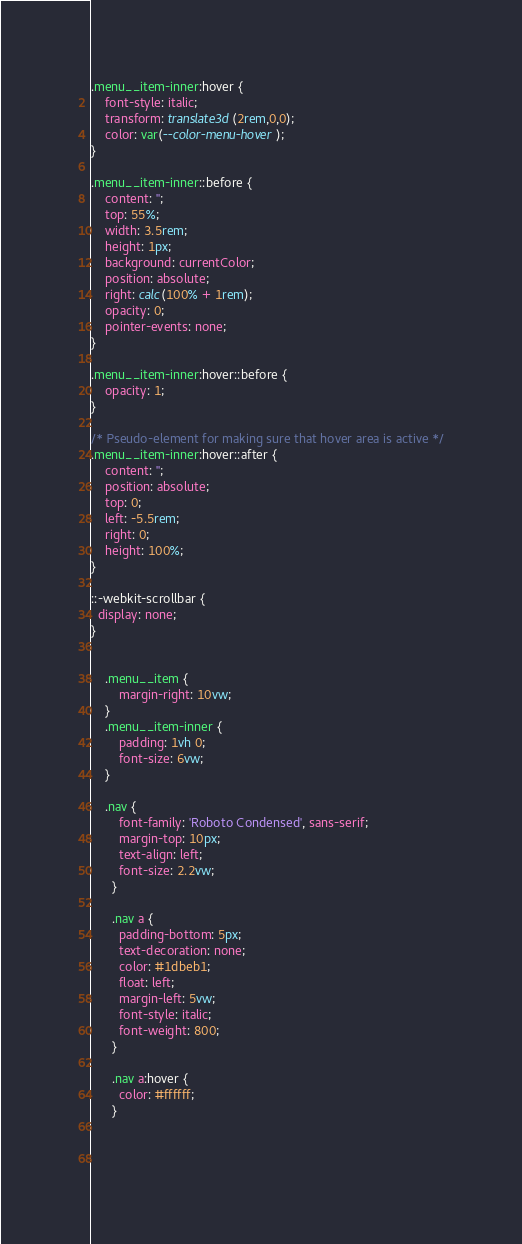<code> <loc_0><loc_0><loc_500><loc_500><_CSS_>.menu__item-inner:hover {
	font-style: italic;
	transform: translate3d(2rem,0,0);
	color: var(--color-menu-hover);
}

.menu__item-inner::before {
	content: '';
	top: 55%;
	width: 3.5rem;
	height: 1px;
	background: currentColor;
	position: absolute;
	right: calc(100% + 1rem);
	opacity: 0;
	pointer-events: none;
}

.menu__item-inner:hover::before {
	opacity: 1;
}

/* Pseudo-element for making sure that hover area is active */
.menu__item-inner:hover::after {
	content: '';
	position: absolute;
	top: 0;
	left: -5.5rem;
	right: 0;
	height: 100%;
}

::-webkit-scrollbar {
  display: none;
}

	
	.menu__item {
		margin-right: 10vw;
	}
	.menu__item-inner {
		padding: 1vh 0;
		font-size: 6vw;
	}

	.nav {
		font-family: 'Roboto Condensed', sans-serif;
		margin-top: 10px;
		text-align: left;
		font-size: 2.2vw;
	  }
	  
	  .nav a {
		padding-bottom: 5px;
		text-decoration: none;
		color: #1dbeb1;
		float: left;
		margin-left: 5vw;
		font-style: italic;
		font-weight: 800;
	  }
	  
	  .nav a:hover {
		color: #ffffff;
	  }


	  
</code> 